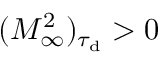Convert formula to latex. <formula><loc_0><loc_0><loc_500><loc_500>( M _ { \infty } ^ { 2 } ) _ { \tau _ { d } } > 0</formula> 